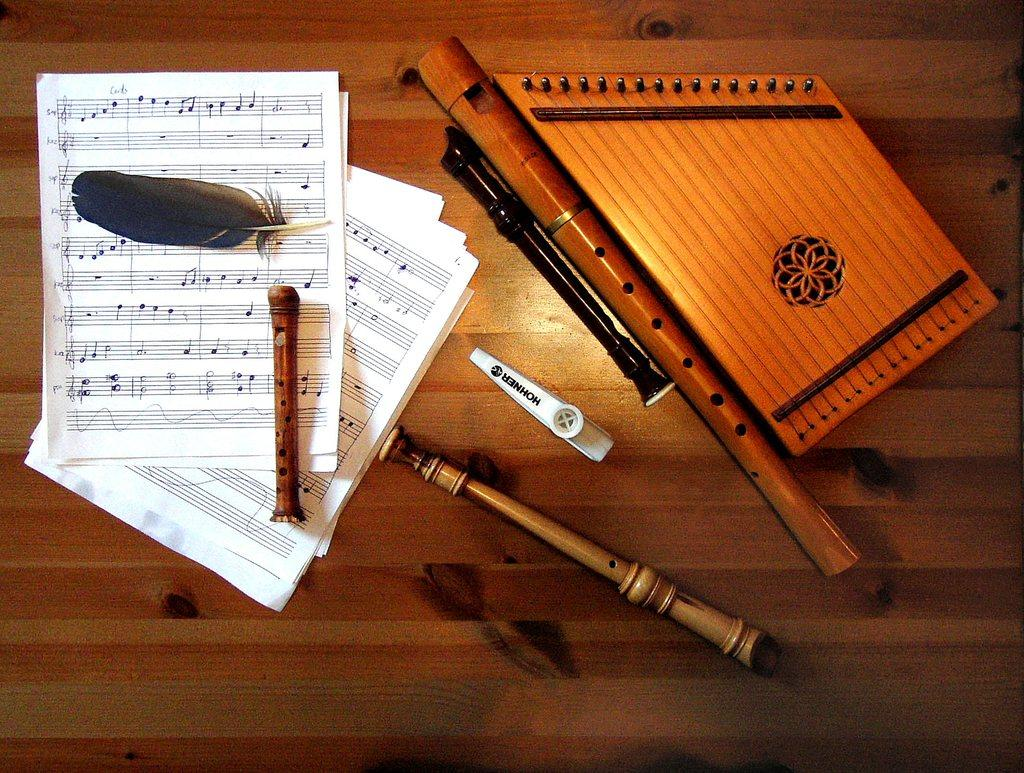What objects in the image have feathers attached to them? There are papers with feathers in the image. What other objects can be seen in the image? There are sticks and musical instruments in the image. What is the color of the white object in the image? The white object in the image is white. On what surface are the objects placed? The objects are placed on a wooden surface. How many trucks are parked near the objects in the image? There are no trucks present in the image. What type of work is being done with the feathers and sticks in the image? There is no indication of any work being done with the feathers and sticks in the image. 